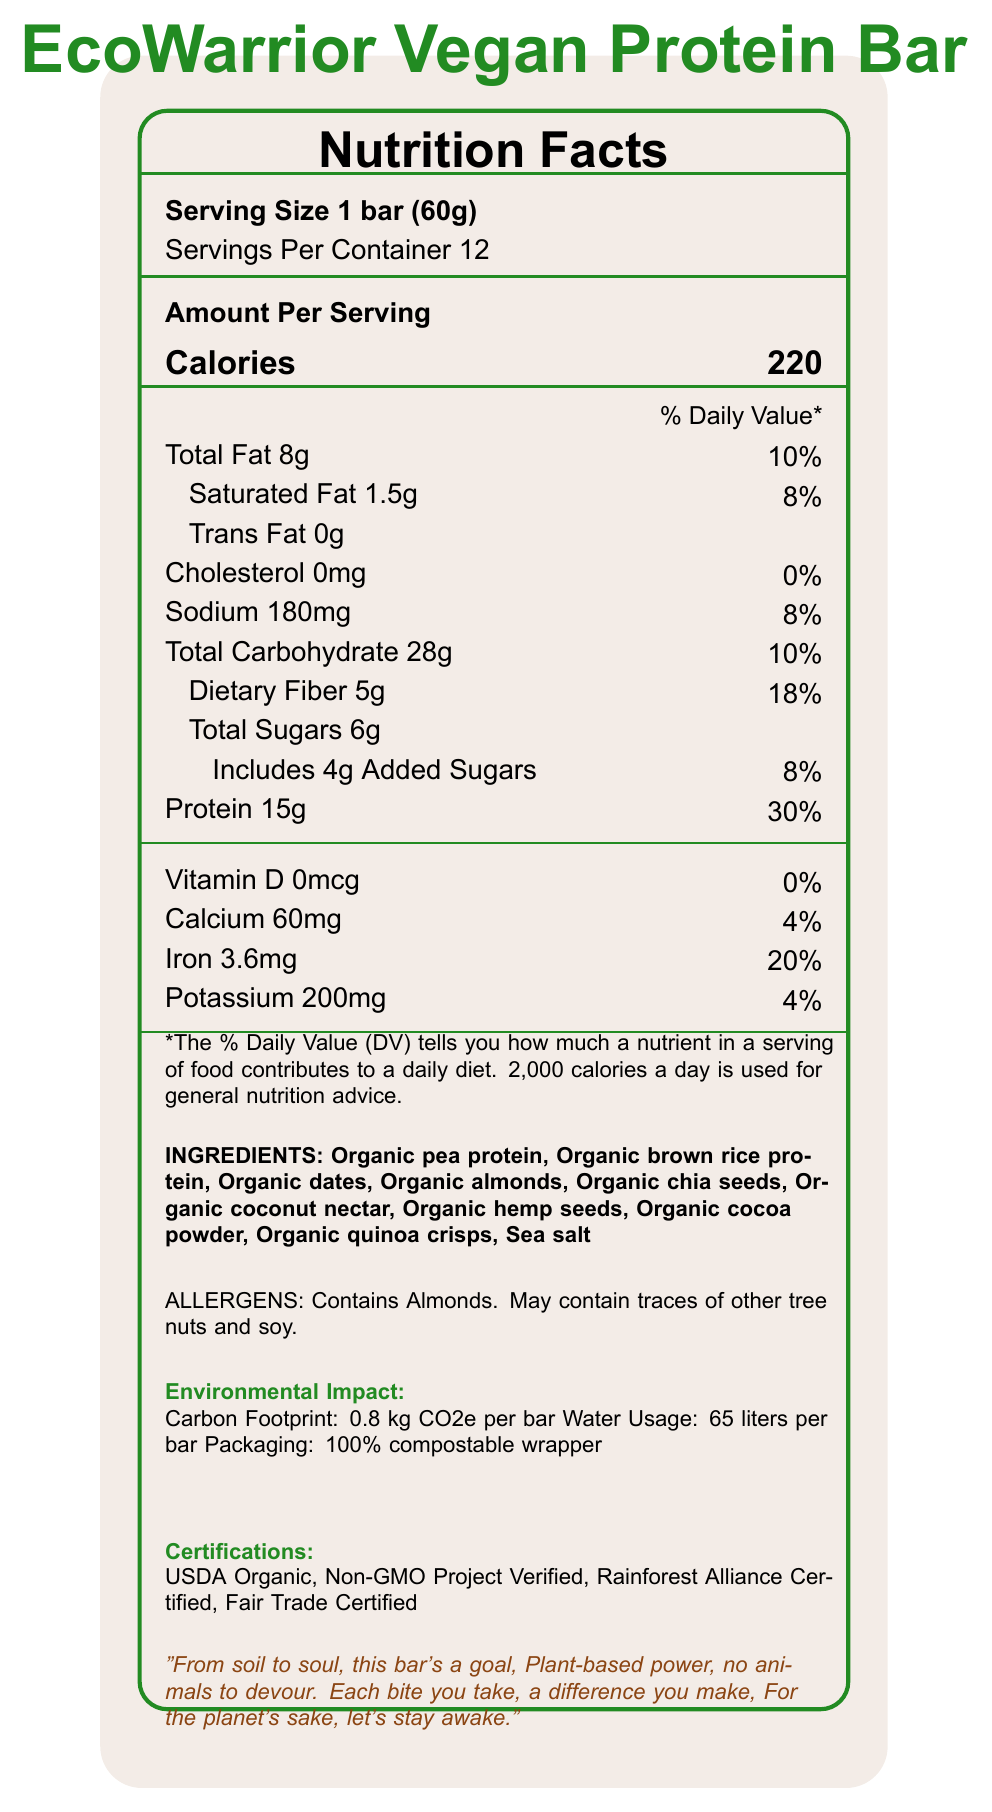what is the serving size of the EcoWarrior Vegan Protein Bar? The document clearly states the serving size as "1 bar (60g)" under the Serving Size section.
Answer: 1 bar (60g) how many calories per serving does the EcoWarrior Vegan Protein Bar have? The document lists the amount of calories per serving as 220 calories under the "Amount Per Serving" section.
Answer: 220 calories name three ingredients found in the EcoWarrior Vegan Protein Bar. The ingredients are listed towards the bottom of the Nutrition Facts section. Three examples are "Organic pea protein," "Organic brown rice protein," and "Organic dates."
Answer: Organic pea protein, Organic brown rice protein, Organic dates what is the percentage daily value of protein per serving? The document states that the percentage daily value of protein per serving is 30%, located next to the protein content information.
Answer: 30% does the EcoWarrior Vegan Protein Bar contain any trans fat? The document specifically lists "Trans Fat 0g," indicating that the bar contains no trans fat.
Answer: No which of the following is NOT an ingredient in the EcoWarrior Vegan Protein Bar: A. Organic dates B. Sea salt C. Organic cashews D. Organic cocoa powder The ingredient list does not include "Organic cashews;" it includes "Organic dates," "Sea salt," and "Organic cocoa powder."
Answer: C. Organic cashews which of these certifications does the EcoWarrior Vegan Protein Bar have? A. USDA Organic B. Non-GMO Project Verified C. Rainforest Alliance Certified D. Fair Trade Certified The document lists all of these certifications: USDA Organic, Non-GMO Project Verified, Rainforest Alliance Certified, and Fair Trade Certified.
Answer: E. All of the above is the calorie content of the protein bar high compared to the usual daily calorie intake? The document provides a general reference that a daily intake is based on 2,000 calories, and with one bar containing 220 calories, it is not considered high.
Answer: No what is the total fat content and its daily value percentage? The document says "Total Fat 8g" with a daily value percentage of "10%," listed under the Amount Per Serving section.
Answer: 8g, 10% can the EcoWarrior Vegan Protein Bar be considered low in cholesterol? The document states "Cholesterol 0mg" which means the bar contains no cholesterol and can be considered low.
Answer: Yes summarize the main idea of the document. This explanation summarizes the detailed information provided in different sections of the document, including nutritional content, ingredients, certifications, environmental impact, and social impact.
Answer: The EcoWarrior Vegan Protein Bar is a plant-based nutritional product offering 220 calories per serving, with key ingredients being organic and plant-based. It is designed to be environmentally friendly, with features such as a low carbon footprint, low water usage, and compostable packaging. It is fortified with 15g of protein per serving and adheres to several certifications including USDA Organic, Non-GMO Project Verified, Rainforest Alliance Certified, and Fair Trade Certified. The product also supports social causes, funding reforestation projects and small-scale organic farmers. The packaging includes a spoken word snippet emphasizing its environmental and health benefits. is the packaging for the EcoWarrior Vegan Protein Bar compostable? The document mentions that the packaging is a "100% compostable wrapper" under the Environmental Impact section.
Answer: Yes how much sodium does one serving of the EcoWarrior Vegan Protein Bar contain? The sodium content per serving is listed as 180mg under the Amount Per Serving section.
Answer: 180mg what kind of reforestation projects does the EcoWarrior Vegan Protein Bar support? The document states that the bar helps fund reforestation projects but does not provide specifics about the kinds of projects supported.
Answer: Not enough information 